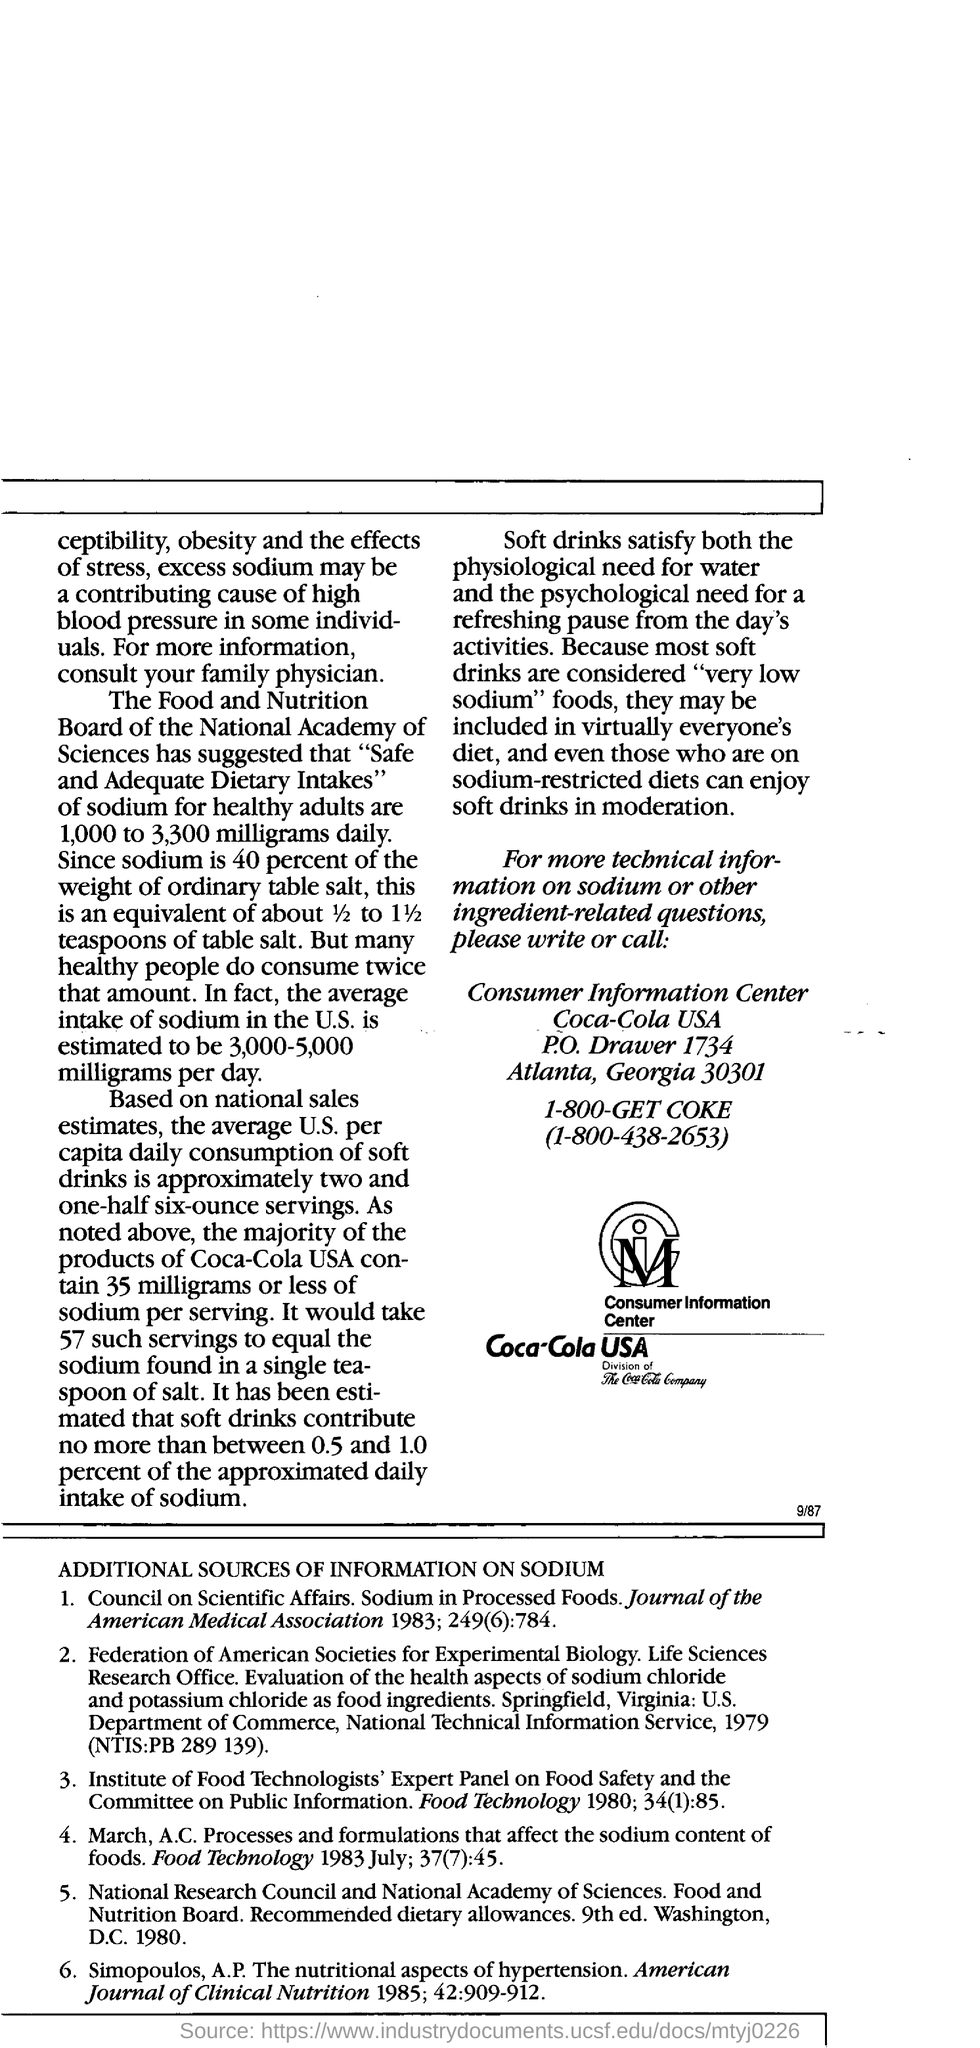What is the average intake of sodium in us ?
Offer a terse response. Estimated to be3000-5000 milligrams per day. What is the  average U.S per capita consumption of soft drinks based on national sales estimates?
Your answer should be compact. Is approximately two and one-half six-ounce servings. What is the estimated average intake of sodium per day in the U.S.?
Make the answer very short. Is estimated to be 3,000-5,000 milligrams per day. What the contact number of  consumer information centre?
Give a very brief answer. 1-800-438-2653. 